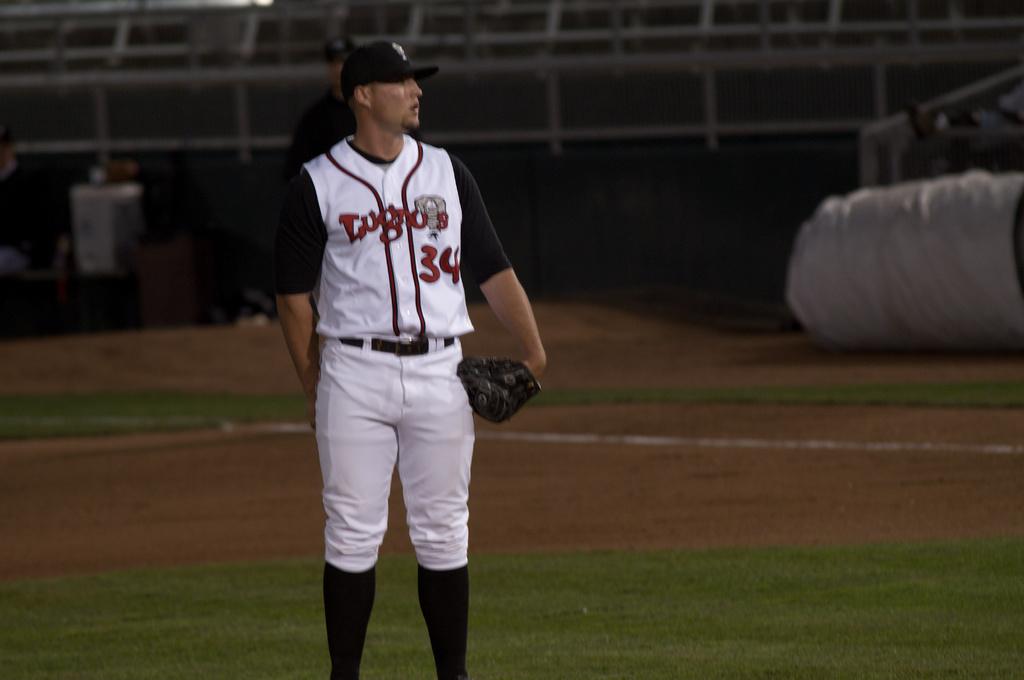What team does he play for?
Offer a very short reply. Lugros. What is his number?
Provide a succinct answer. 34. 